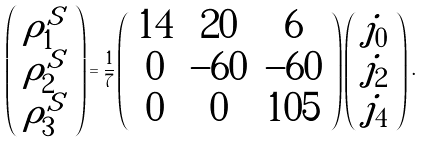Convert formula to latex. <formula><loc_0><loc_0><loc_500><loc_500>\left ( \begin{array} { c } \rho _ { 1 } ^ { S } \\ \rho _ { 2 } ^ { S } \\ \rho _ { 3 } ^ { S } \end{array} \right ) = \frac { 1 } { 7 } \left ( \begin{array} { c c c } 1 4 & 2 0 & 6 \\ 0 & - 6 0 & - 6 0 \\ 0 & 0 & 1 0 5 \end{array} \right ) \left ( \begin{array} { c } j _ { 0 } \\ j _ { 2 } \\ j _ { 4 } \end{array} \right ) \, .</formula> 